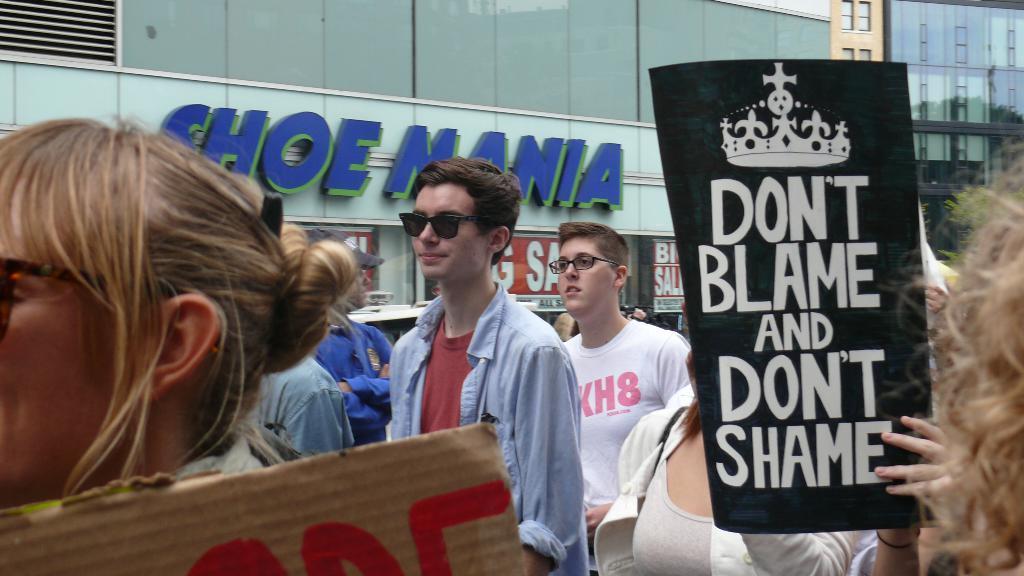Can you describe this image briefly? Here in this picture we can see a group of people standing over a place and some of them are holding placards and we can see some of them are wearing goggles and spectacles and beside them we can see stores and buildings with number of windows present. 